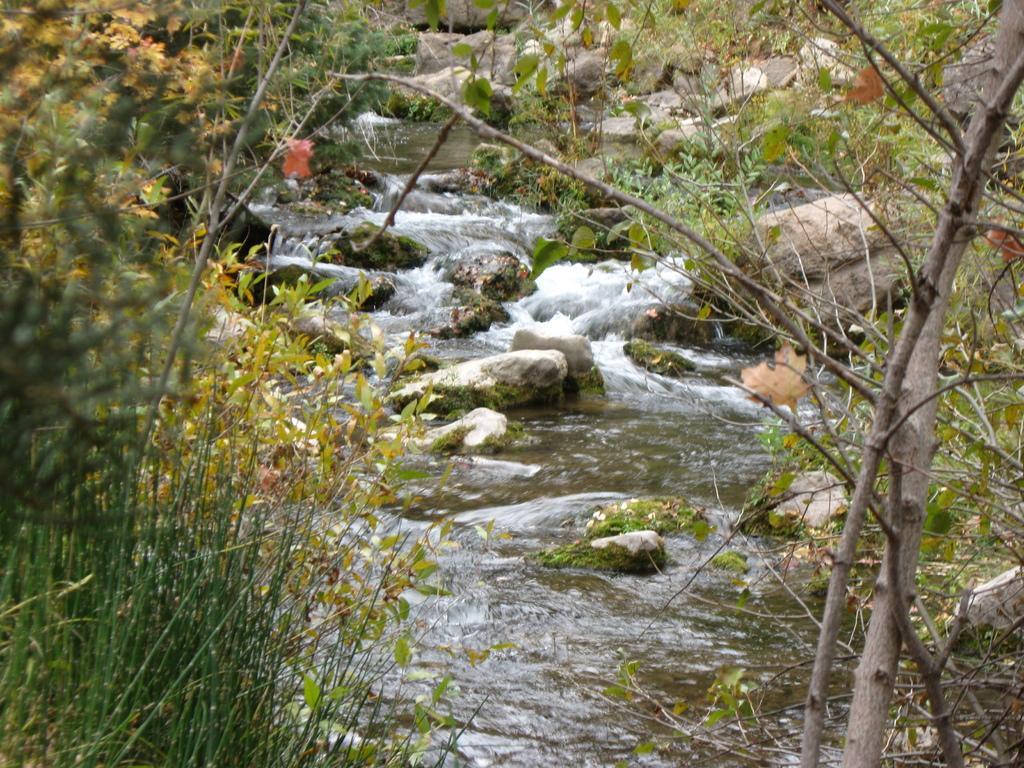Could you give a brief overview of what you see in this image? I the image we can see there are many trees, plants and water. There are many big stones. 